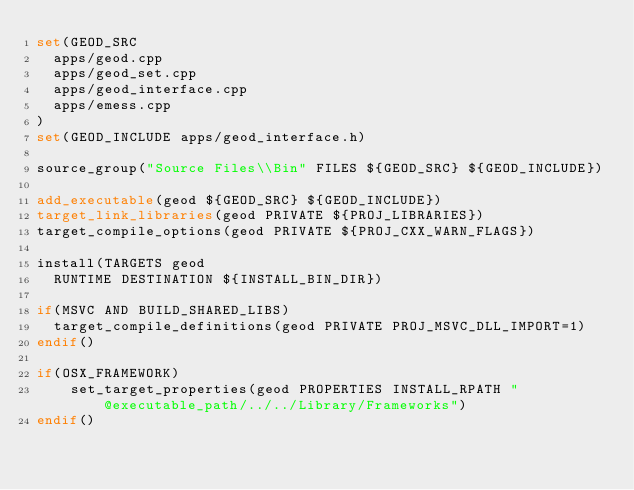<code> <loc_0><loc_0><loc_500><loc_500><_CMake_>set(GEOD_SRC
  apps/geod.cpp
  apps/geod_set.cpp
  apps/geod_interface.cpp
  apps/emess.cpp
)
set(GEOD_INCLUDE apps/geod_interface.h)

source_group("Source Files\\Bin" FILES ${GEOD_SRC} ${GEOD_INCLUDE})

add_executable(geod ${GEOD_SRC} ${GEOD_INCLUDE})
target_link_libraries(geod PRIVATE ${PROJ_LIBRARIES})
target_compile_options(geod PRIVATE ${PROJ_CXX_WARN_FLAGS})

install(TARGETS geod
  RUNTIME DESTINATION ${INSTALL_BIN_DIR})

if(MSVC AND BUILD_SHARED_LIBS)
  target_compile_definitions(geod PRIVATE PROJ_MSVC_DLL_IMPORT=1)
endif()

if(OSX_FRAMEWORK)
    set_target_properties(geod PROPERTIES INSTALL_RPATH "@executable_path/../../Library/Frameworks")
endif()</code> 